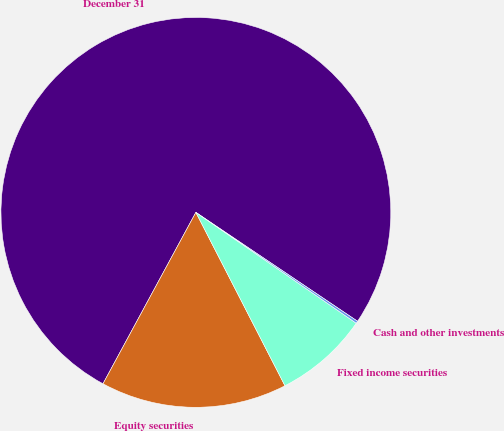<chart> <loc_0><loc_0><loc_500><loc_500><pie_chart><fcel>December 31<fcel>Equity securities<fcel>Fixed income securities<fcel>Cash and other investments<nl><fcel>76.53%<fcel>15.46%<fcel>7.82%<fcel>0.19%<nl></chart> 